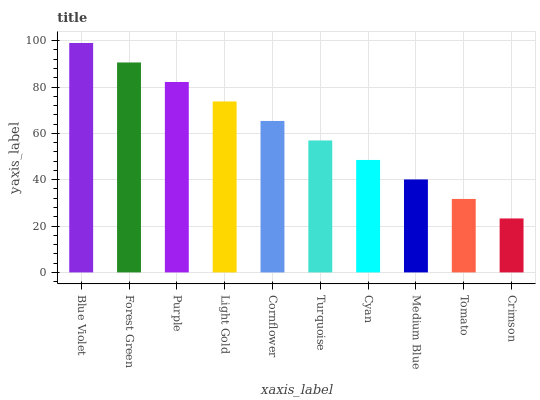Is Crimson the minimum?
Answer yes or no. Yes. Is Blue Violet the maximum?
Answer yes or no. Yes. Is Forest Green the minimum?
Answer yes or no. No. Is Forest Green the maximum?
Answer yes or no. No. Is Blue Violet greater than Forest Green?
Answer yes or no. Yes. Is Forest Green less than Blue Violet?
Answer yes or no. Yes. Is Forest Green greater than Blue Violet?
Answer yes or no. No. Is Blue Violet less than Forest Green?
Answer yes or no. No. Is Cornflower the high median?
Answer yes or no. Yes. Is Turquoise the low median?
Answer yes or no. Yes. Is Purple the high median?
Answer yes or no. No. Is Purple the low median?
Answer yes or no. No. 